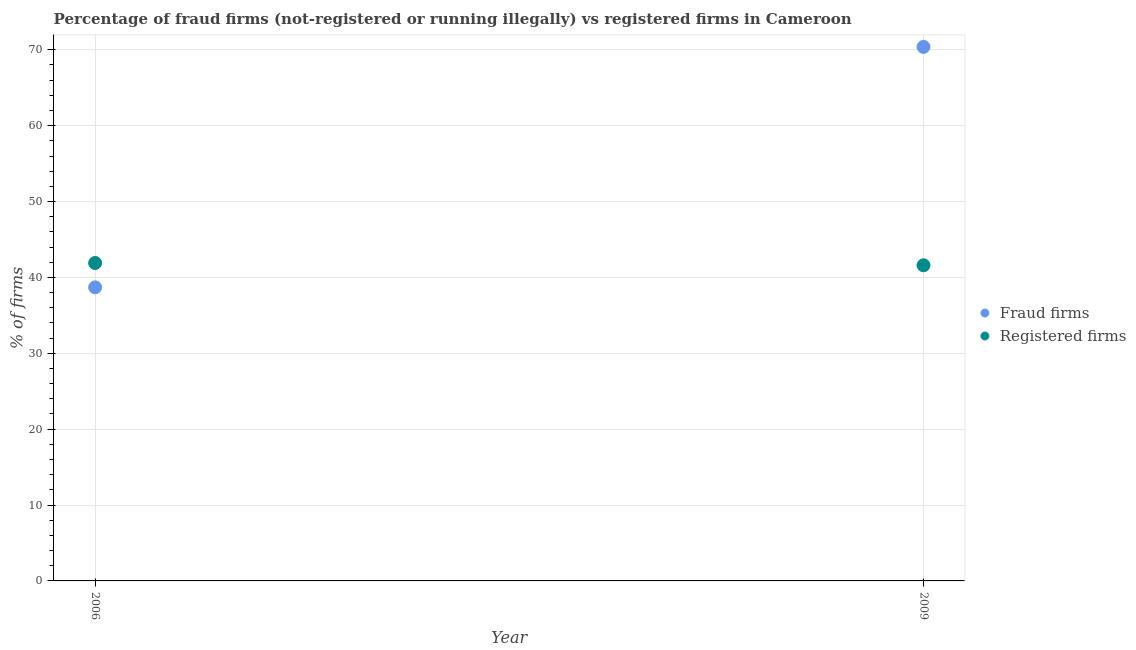How many different coloured dotlines are there?
Provide a short and direct response. 2. Is the number of dotlines equal to the number of legend labels?
Provide a short and direct response. Yes. What is the percentage of registered firms in 2009?
Provide a succinct answer. 41.6. Across all years, what is the maximum percentage of registered firms?
Ensure brevity in your answer.  41.9. Across all years, what is the minimum percentage of fraud firms?
Make the answer very short. 38.69. In which year was the percentage of fraud firms maximum?
Ensure brevity in your answer.  2009. In which year was the percentage of registered firms minimum?
Provide a short and direct response. 2009. What is the total percentage of registered firms in the graph?
Provide a short and direct response. 83.5. What is the difference between the percentage of registered firms in 2006 and that in 2009?
Give a very brief answer. 0.3. What is the difference between the percentage of fraud firms in 2006 and the percentage of registered firms in 2009?
Your response must be concise. -2.91. What is the average percentage of registered firms per year?
Your response must be concise. 41.75. In the year 2006, what is the difference between the percentage of registered firms and percentage of fraud firms?
Your answer should be very brief. 3.21. What is the ratio of the percentage of fraud firms in 2006 to that in 2009?
Make the answer very short. 0.55. Is the percentage of registered firms in 2006 less than that in 2009?
Provide a succinct answer. No. Does the percentage of registered firms monotonically increase over the years?
Offer a very short reply. No. Is the percentage of fraud firms strictly greater than the percentage of registered firms over the years?
Your answer should be very brief. No. How many dotlines are there?
Your answer should be very brief. 2. How many years are there in the graph?
Give a very brief answer. 2. What is the difference between two consecutive major ticks on the Y-axis?
Make the answer very short. 10. How many legend labels are there?
Your answer should be compact. 2. How are the legend labels stacked?
Keep it short and to the point. Vertical. What is the title of the graph?
Your response must be concise. Percentage of fraud firms (not-registered or running illegally) vs registered firms in Cameroon. What is the label or title of the Y-axis?
Keep it short and to the point. % of firms. What is the % of firms in Fraud firms in 2006?
Your answer should be compact. 38.69. What is the % of firms of Registered firms in 2006?
Your answer should be compact. 41.9. What is the % of firms of Fraud firms in 2009?
Keep it short and to the point. 70.38. What is the % of firms of Registered firms in 2009?
Ensure brevity in your answer.  41.6. Across all years, what is the maximum % of firms in Fraud firms?
Offer a very short reply. 70.38. Across all years, what is the maximum % of firms of Registered firms?
Ensure brevity in your answer.  41.9. Across all years, what is the minimum % of firms in Fraud firms?
Keep it short and to the point. 38.69. Across all years, what is the minimum % of firms of Registered firms?
Your response must be concise. 41.6. What is the total % of firms of Fraud firms in the graph?
Your answer should be very brief. 109.07. What is the total % of firms in Registered firms in the graph?
Provide a succinct answer. 83.5. What is the difference between the % of firms of Fraud firms in 2006 and that in 2009?
Give a very brief answer. -31.69. What is the difference between the % of firms in Registered firms in 2006 and that in 2009?
Offer a terse response. 0.3. What is the difference between the % of firms of Fraud firms in 2006 and the % of firms of Registered firms in 2009?
Offer a very short reply. -2.91. What is the average % of firms of Fraud firms per year?
Give a very brief answer. 54.53. What is the average % of firms in Registered firms per year?
Provide a succinct answer. 41.75. In the year 2006, what is the difference between the % of firms of Fraud firms and % of firms of Registered firms?
Offer a terse response. -3.21. In the year 2009, what is the difference between the % of firms in Fraud firms and % of firms in Registered firms?
Offer a terse response. 28.78. What is the ratio of the % of firms of Fraud firms in 2006 to that in 2009?
Ensure brevity in your answer.  0.55. What is the ratio of the % of firms of Registered firms in 2006 to that in 2009?
Keep it short and to the point. 1.01. What is the difference between the highest and the second highest % of firms in Fraud firms?
Make the answer very short. 31.69. What is the difference between the highest and the second highest % of firms of Registered firms?
Your response must be concise. 0.3. What is the difference between the highest and the lowest % of firms of Fraud firms?
Keep it short and to the point. 31.69. What is the difference between the highest and the lowest % of firms in Registered firms?
Your answer should be compact. 0.3. 